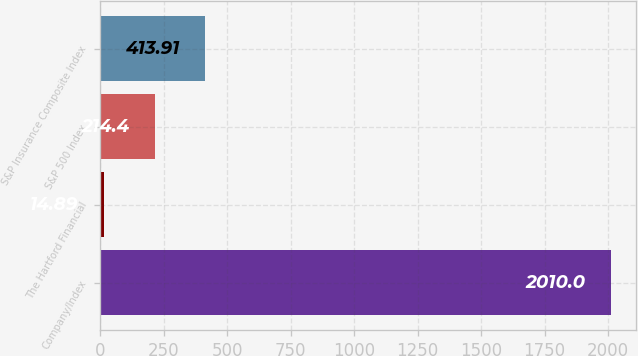Convert chart. <chart><loc_0><loc_0><loc_500><loc_500><bar_chart><fcel>Company/Index<fcel>The Hartford Financial<fcel>S&P 500 Index<fcel>S&P Insurance Composite Index<nl><fcel>2010<fcel>14.89<fcel>214.4<fcel>413.91<nl></chart> 